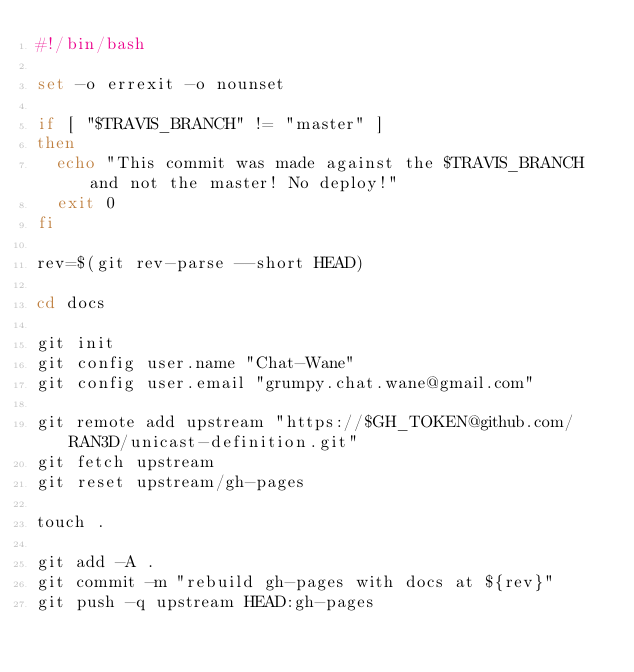<code> <loc_0><loc_0><loc_500><loc_500><_Bash_>#!/bin/bash

set -o errexit -o nounset

if [ "$TRAVIS_BRANCH" != "master" ]
then
  echo "This commit was made against the $TRAVIS_BRANCH and not the master! No deploy!"
  exit 0
fi

rev=$(git rev-parse --short HEAD)

cd docs

git init
git config user.name "Chat-Wane"
git config user.email "grumpy.chat.wane@gmail.com"

git remote add upstream "https://$GH_TOKEN@github.com/RAN3D/unicast-definition.git"
git fetch upstream
git reset upstream/gh-pages

touch .

git add -A .
git commit -m "rebuild gh-pages with docs at ${rev}"
git push -q upstream HEAD:gh-pages
</code> 